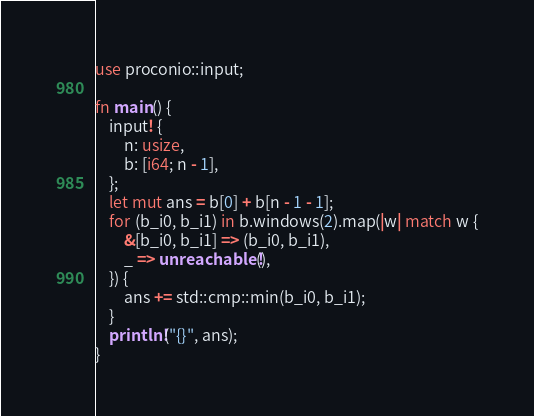<code> <loc_0><loc_0><loc_500><loc_500><_Rust_>use proconio::input;

fn main() {
    input! {
        n: usize,
        b: [i64; n - 1],
    };
    let mut ans = b[0] + b[n - 1 - 1];
    for (b_i0, b_i1) in b.windows(2).map(|w| match w {
        &[b_i0, b_i1] => (b_i0, b_i1),
        _ => unreachable!(),
    }) {
        ans += std::cmp::min(b_i0, b_i1);
    }
    println!("{}", ans);
}
</code> 